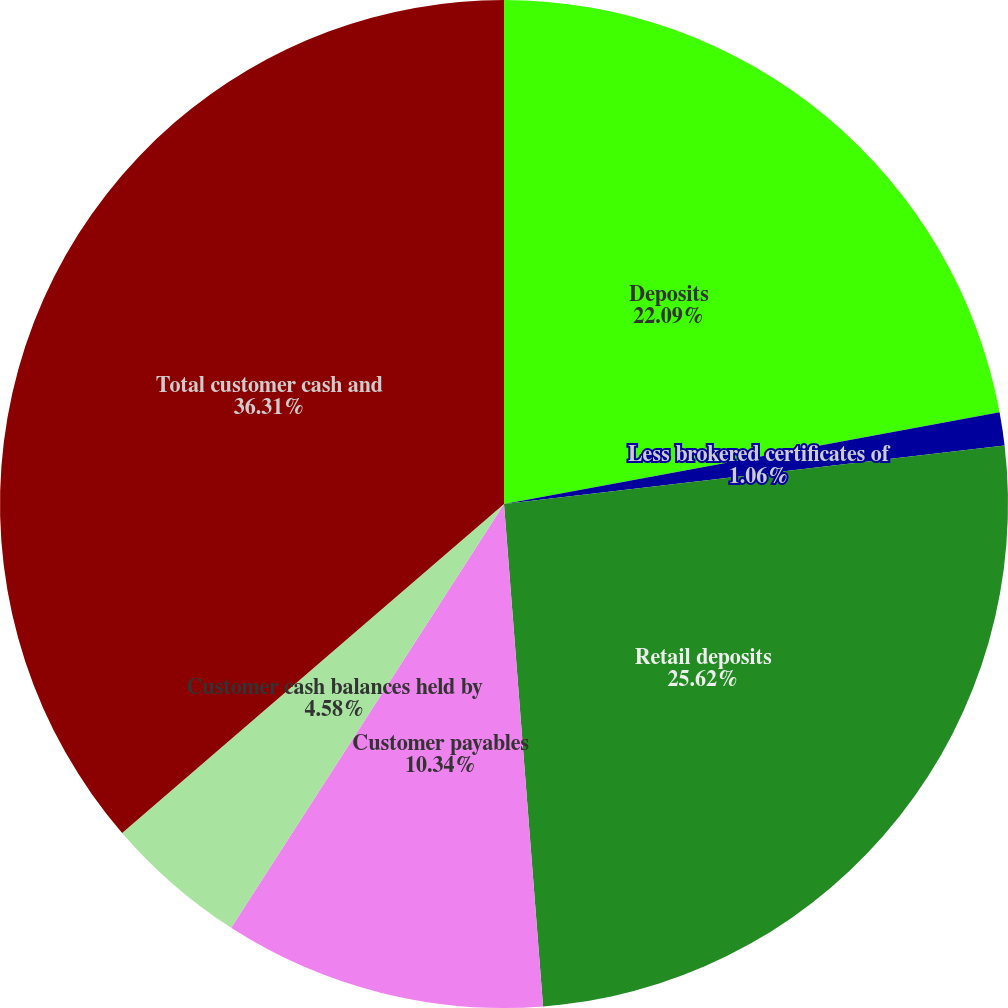<chart> <loc_0><loc_0><loc_500><loc_500><pie_chart><fcel>Deposits<fcel>Less brokered certificates of<fcel>Retail deposits<fcel>Customer payables<fcel>Customer cash balances held by<fcel>Total customer cash and<nl><fcel>22.09%<fcel>1.06%<fcel>25.62%<fcel>10.34%<fcel>4.58%<fcel>36.32%<nl></chart> 